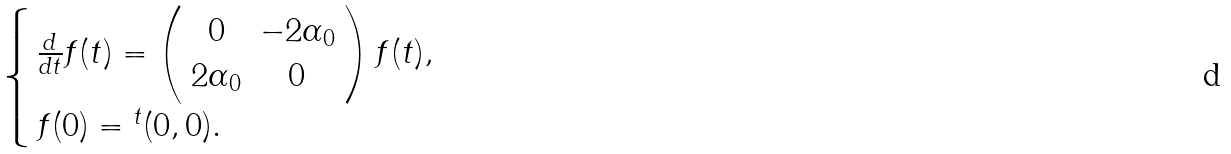<formula> <loc_0><loc_0><loc_500><loc_500>\begin{cases} \, \frac { d } { d t } f ( t ) = \left ( \begin{array} { c c } 0 & - 2 \alpha _ { 0 } \\ 2 \alpha _ { 0 } & 0 \\ \end{array} \right ) f ( t ) , \\ \, f ( 0 ) = { ^ { t } ( 0 , 0 ) } . \end{cases}</formula> 